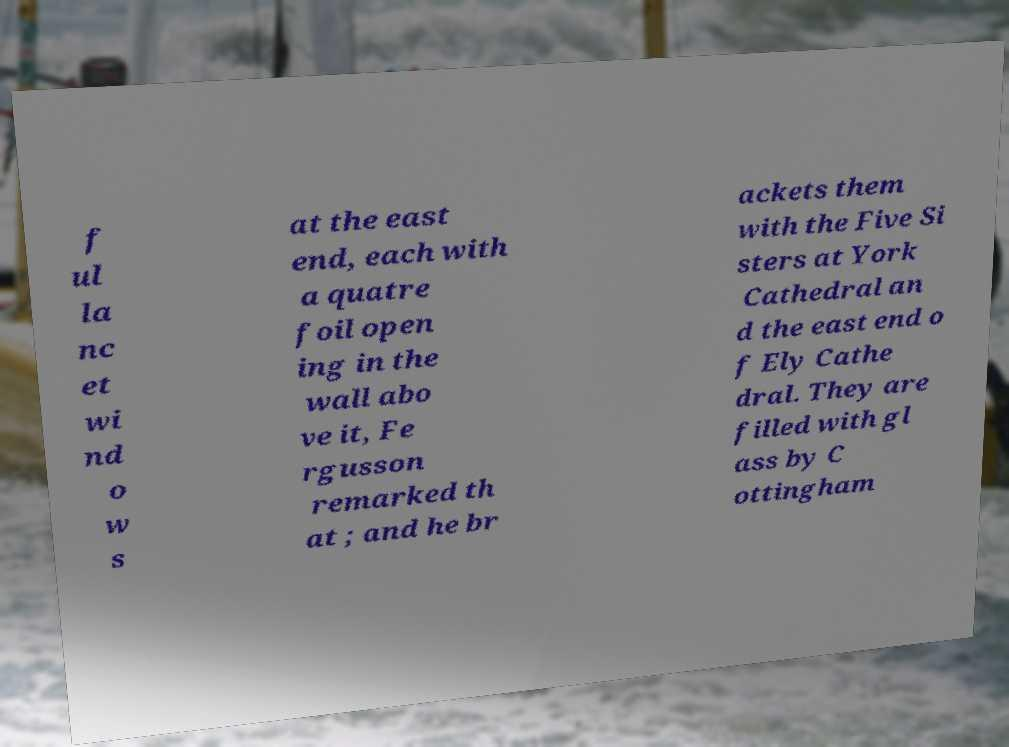Can you read and provide the text displayed in the image?This photo seems to have some interesting text. Can you extract and type it out for me? f ul la nc et wi nd o w s at the east end, each with a quatre foil open ing in the wall abo ve it, Fe rgusson remarked th at ; and he br ackets them with the Five Si sters at York Cathedral an d the east end o f Ely Cathe dral. They are filled with gl ass by C ottingham 